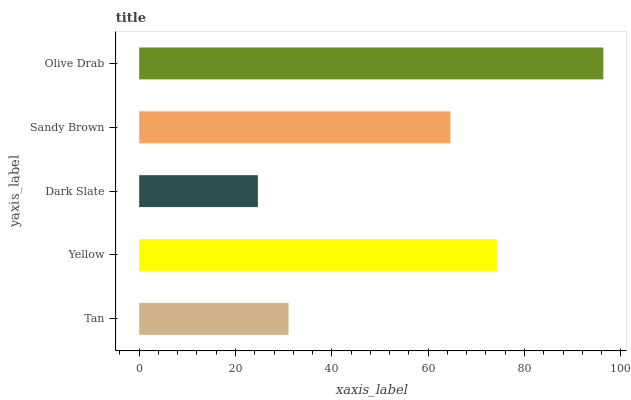Is Dark Slate the minimum?
Answer yes or no. Yes. Is Olive Drab the maximum?
Answer yes or no. Yes. Is Yellow the minimum?
Answer yes or no. No. Is Yellow the maximum?
Answer yes or no. No. Is Yellow greater than Tan?
Answer yes or no. Yes. Is Tan less than Yellow?
Answer yes or no. Yes. Is Tan greater than Yellow?
Answer yes or no. No. Is Yellow less than Tan?
Answer yes or no. No. Is Sandy Brown the high median?
Answer yes or no. Yes. Is Sandy Brown the low median?
Answer yes or no. Yes. Is Dark Slate the high median?
Answer yes or no. No. Is Tan the low median?
Answer yes or no. No. 